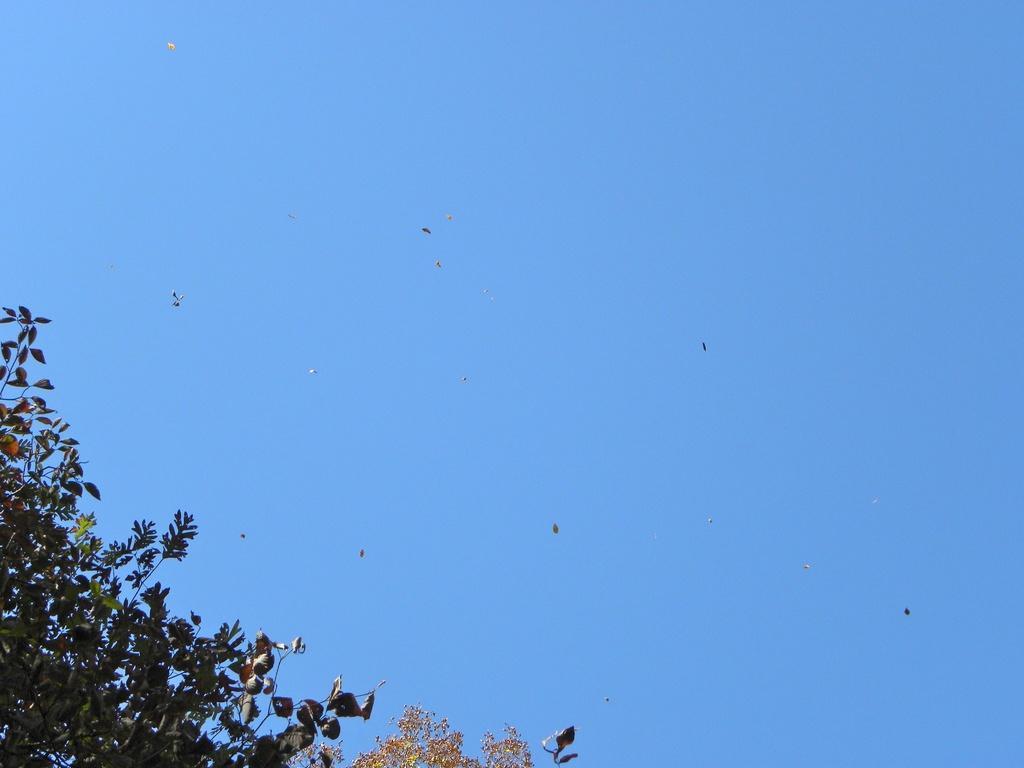Can you describe this image briefly? In this image, we can see the sky. At the bottom, we can see tree leaves with stems. 